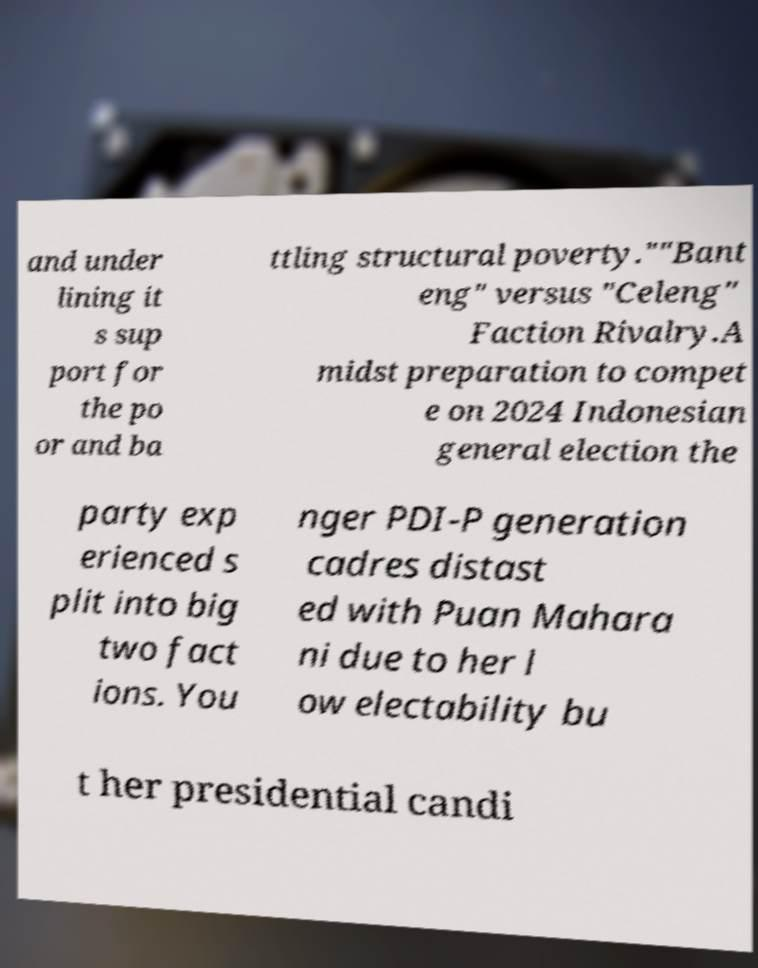There's text embedded in this image that I need extracted. Can you transcribe it verbatim? and under lining it s sup port for the po or and ba ttling structural poverty.""Bant eng" versus "Celeng" Faction Rivalry.A midst preparation to compet e on 2024 Indonesian general election the party exp erienced s plit into big two fact ions. You nger PDI-P generation cadres distast ed with Puan Mahara ni due to her l ow electability bu t her presidential candi 